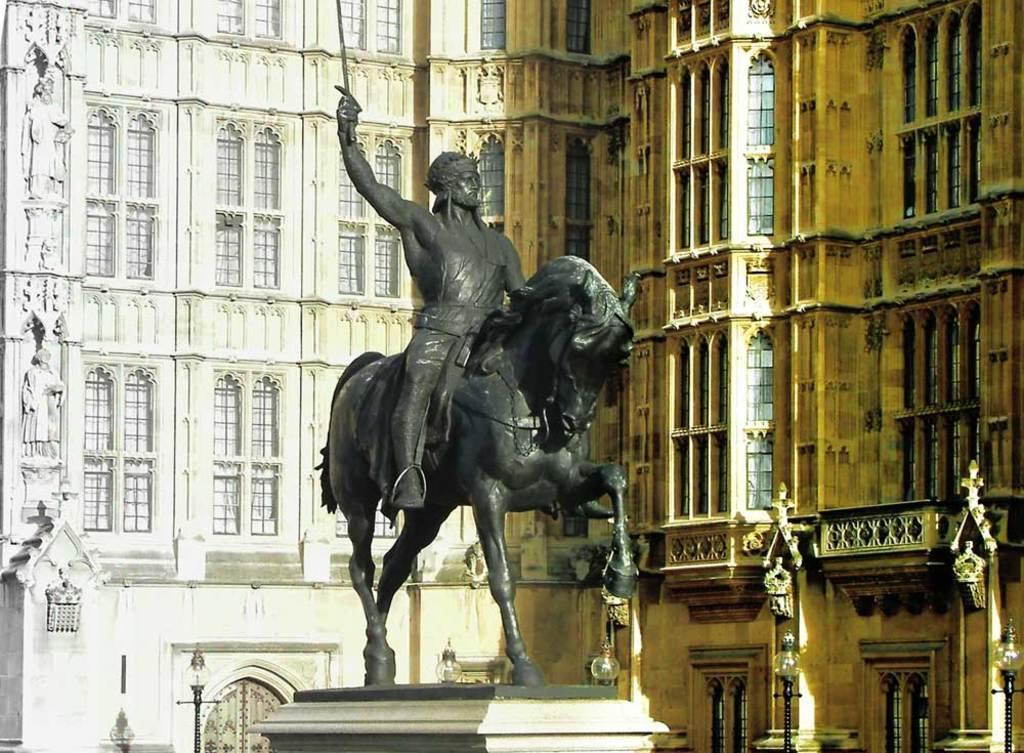In one or two sentences, can you explain what this image depicts? In this picture we can see a statue. There are a few street lights and buildings in the background. We can see windows on these buildings. 